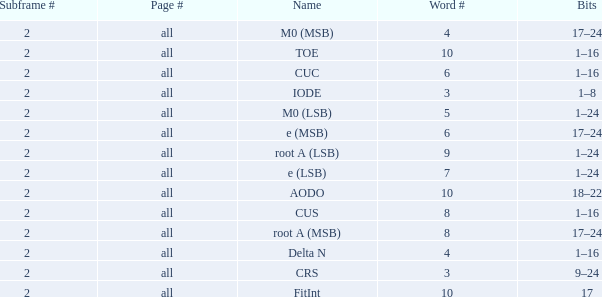Could you parse the entire table as a dict? {'header': ['Subframe #', 'Page #', 'Name', 'Word #', 'Bits'], 'rows': [['2', 'all', 'M0 (MSB)', '4', '17–24'], ['2', 'all', 'TOE', '10', '1–16'], ['2', 'all', 'CUC', '6', '1–16'], ['2', 'all', 'IODE', '3', '1–8'], ['2', 'all', 'M0 (LSB)', '5', '1–24'], ['2', 'all', 'e (MSB)', '6', '17–24'], ['2', 'all', 'root A (LSB)', '9', '1–24'], ['2', 'all', 'e (LSB)', '7', '1–24'], ['2', 'all', 'AODO', '10', '18–22'], ['2', 'all', 'CUS', '8', '1–16'], ['2', 'all', 'root A (MSB)', '8', '17–24'], ['2', 'all', 'Delta N', '4', '1–16'], ['2', 'all', 'CRS', '3', '9–24'], ['2', 'all', 'FitInt', '10', '17']]} What is the total subframe count with Bits of 18–22? 2.0. 